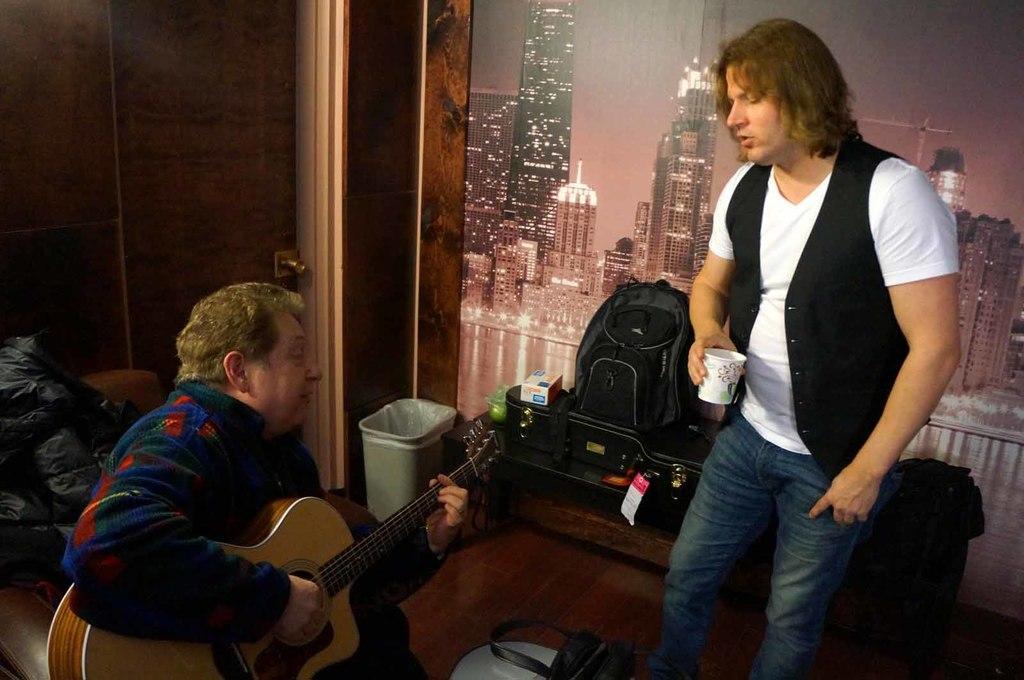Describe this image in one or two sentences. In this picture we can see a man playing guitar and near to him we can see other man standing and holding a glass in his hand. This is a floor. This is a trash can. Here on the table we can see a backpack and a box. Here we can see a frame , where we can see buildings. This is a door. 